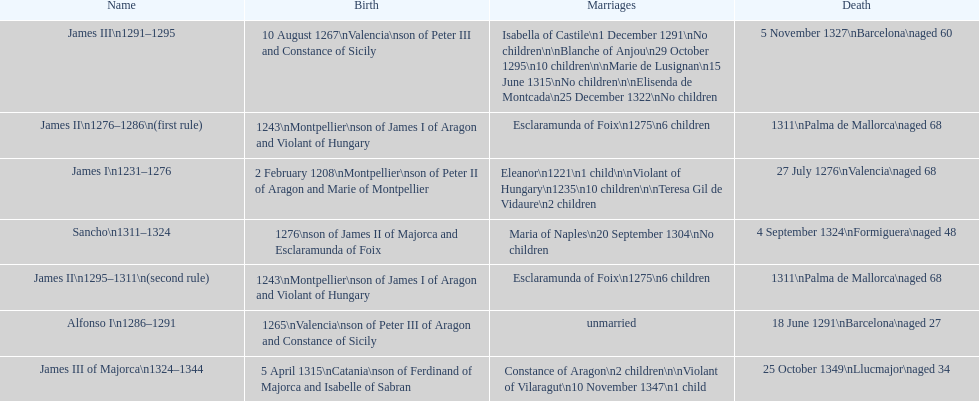How many total marriages did james i have? 3. 